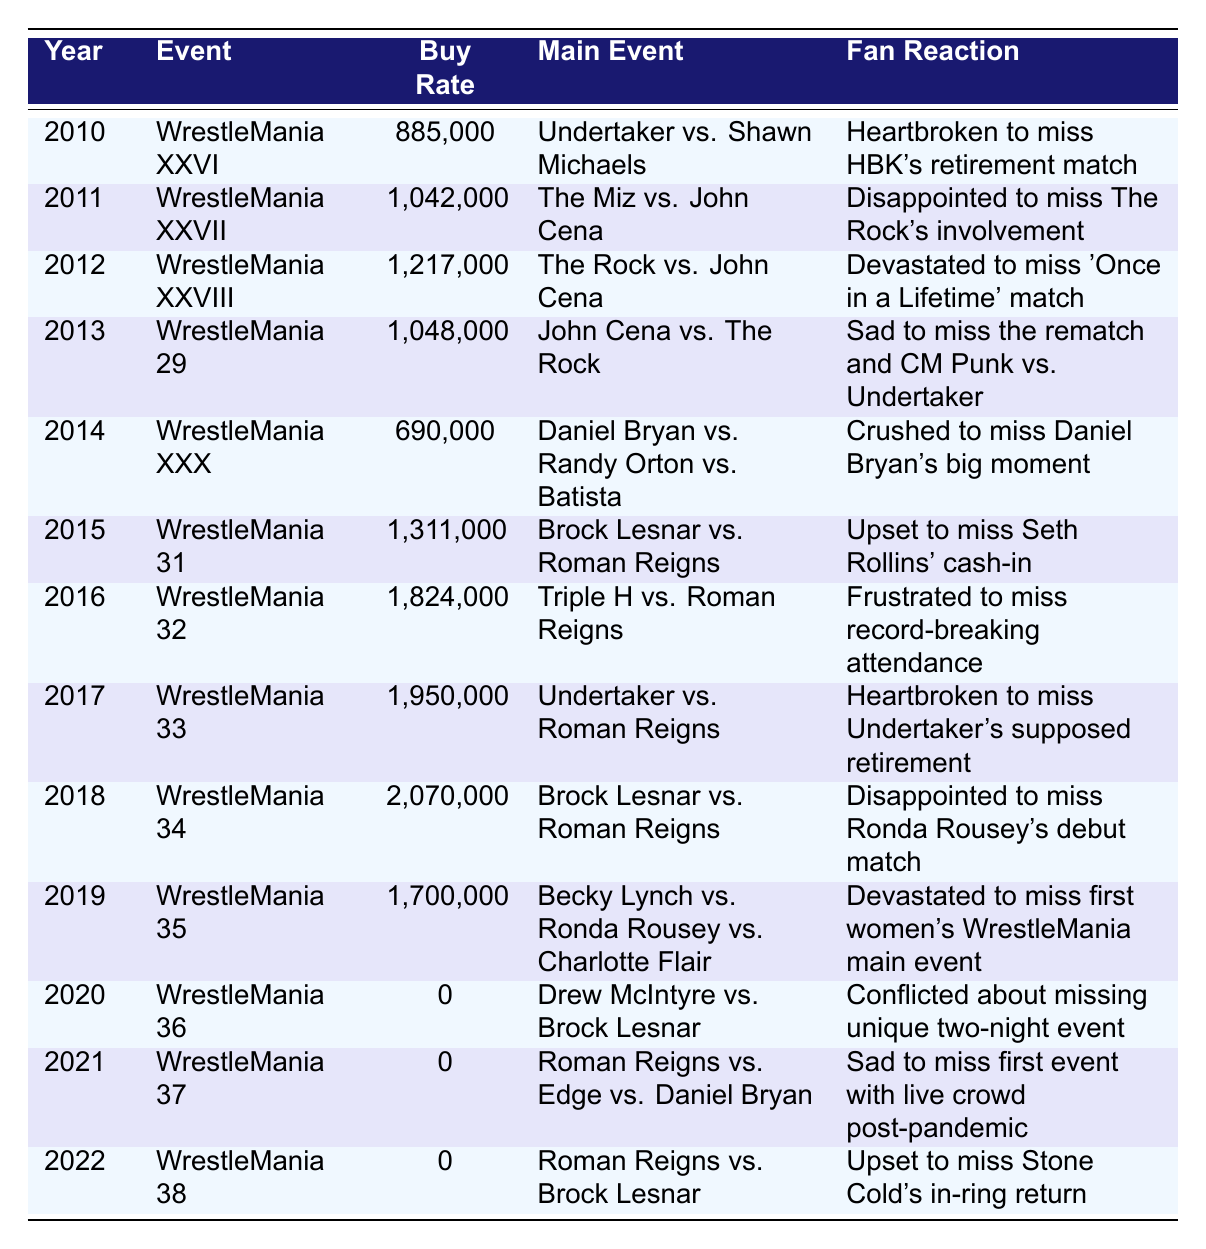What was the buy rate for WrestleMania 31? The table indicates that the buy rate for WrestleMania 31 in 2015 was 1,311,000.
Answer: 1,311,000 Which event had the highest buy rate? According to the table, WrestleMania 38 had the highest buy rate of 2,070,000 in 2018.
Answer: 2,070,000 In which year did fans express disappointment about missing Ronda Rousey’s debut match? The table shows that fans were disappointed to miss Ronda Rousey's debut match during WrestleMania 34 in 2018.
Answer: 2018 How many events had a buy rate of 0? The table lists three events with a buy rate of 0, which occurred in 2020, 2021, and 2022.
Answer: 3 What is the total buy rate for WrestleMania events from 2010 to 2019? By adding the buy rates for the years 2010 to 2019: 885,000 + 1,042,000 + 1,217,000 + 1,048,000 + 690,000 + 1,311,000 + 1,824,000 + 1,950,000 + 2,070,000 + 1,700,000 = 12,737,000.
Answer: 12,737,000 Was there any event in 2021 that had an announced buy rate? The table reveals that WrestleMania 37 in 2021 had a buy rate of 0, indicating that no buy rate was reported.
Answer: No Which main event had the lowest buy rate and what was that number? The table indicates that WrestleMania XXX in 2014 had the lowest buy rate of 690,000.
Answer: 690,000 How did the buy rate for WrestleMania 29 compare to WrestleMania 28? WrestleMania 28 had a buy rate of 1,217,000, while WrestleMania 29 had a buy rate of 1,048,000, meaning 28 had 169,000 more buys than 29.
Answer: WrestleMania 28 had 169,000 more buys What was the main event of the year with the second-highest buy rate? WrestleMania 34 had the second-highest buy rate of 2,070,000, and the main event was Brock Lesnar vs. Roman Reigns.
Answer: Brock Lesnar vs. Roman Reigns Which year recorded a record-breaking attendance, and what was the buy rate for that event? In 2016, WrestleMania 32 recorded a record-breaking attendance, and its buy rate was 1,824,000.
Answer: 1,824,000 